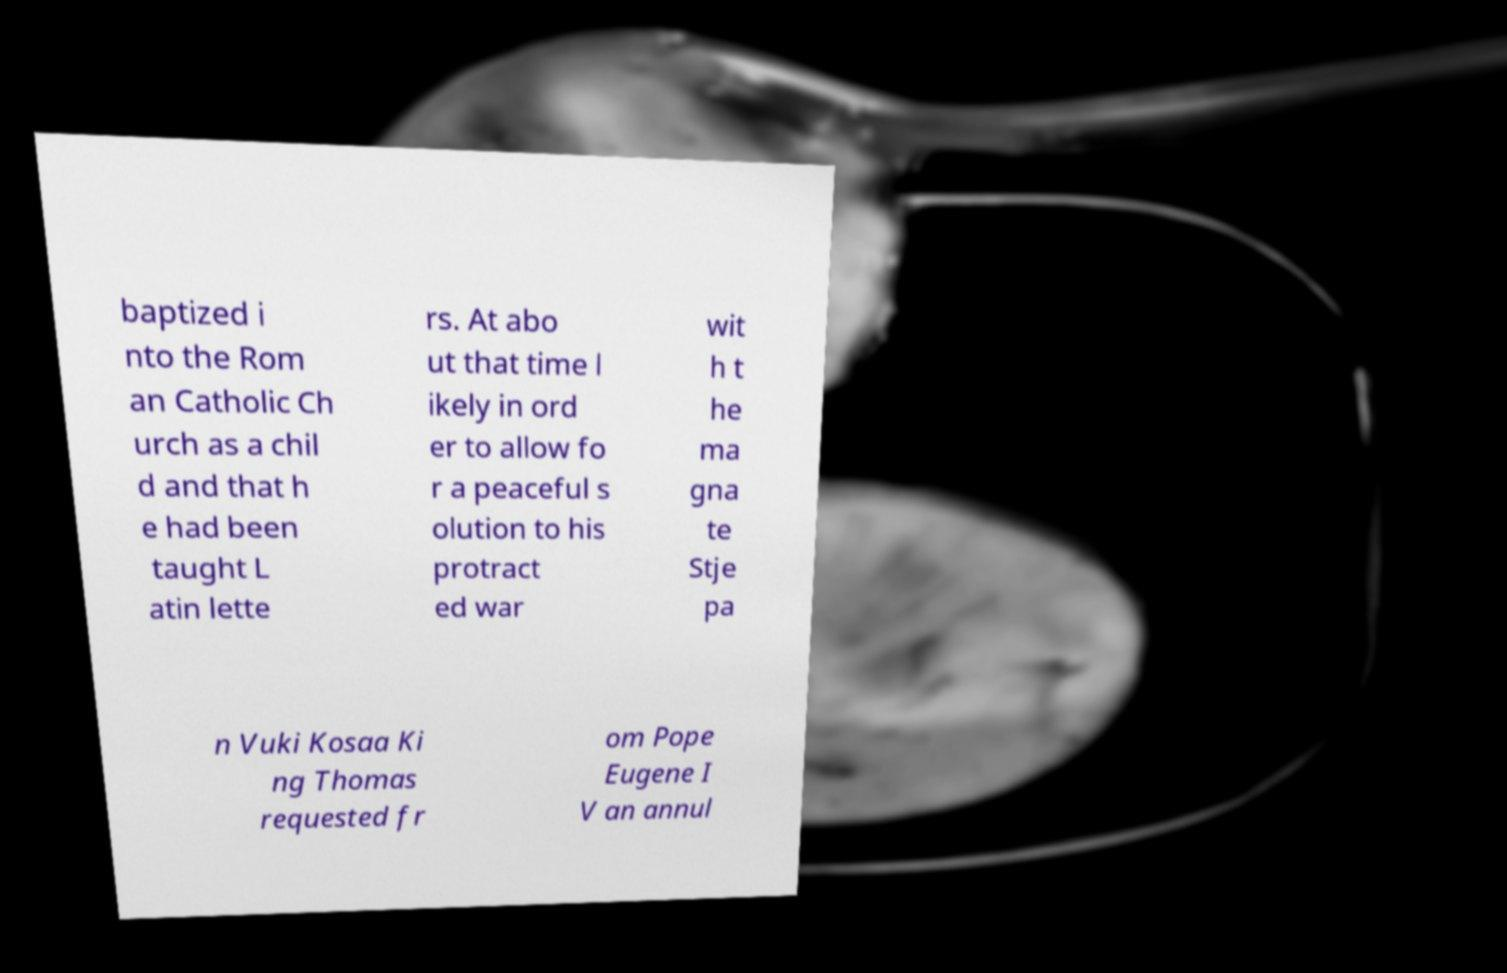Please read and relay the text visible in this image. What does it say? baptized i nto the Rom an Catholic Ch urch as a chil d and that h e had been taught L atin lette rs. At abo ut that time l ikely in ord er to allow fo r a peaceful s olution to his protract ed war wit h t he ma gna te Stje pa n Vuki Kosaa Ki ng Thomas requested fr om Pope Eugene I V an annul 